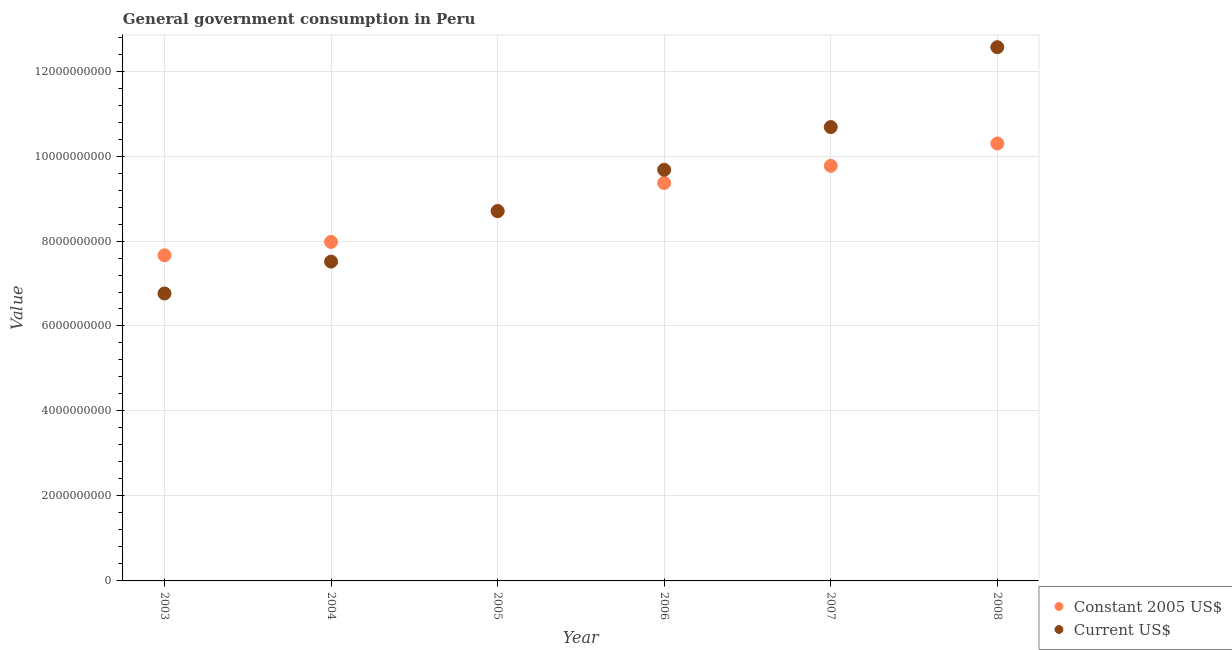Is the number of dotlines equal to the number of legend labels?
Give a very brief answer. Yes. What is the value consumed in current us$ in 2007?
Provide a short and direct response. 1.07e+1. Across all years, what is the maximum value consumed in constant 2005 us$?
Offer a very short reply. 1.03e+1. Across all years, what is the minimum value consumed in current us$?
Give a very brief answer. 6.77e+09. In which year was the value consumed in current us$ minimum?
Give a very brief answer. 2003. What is the total value consumed in current us$ in the graph?
Your response must be concise. 5.59e+1. What is the difference between the value consumed in constant 2005 us$ in 2007 and that in 2008?
Keep it short and to the point. -5.27e+08. What is the difference between the value consumed in constant 2005 us$ in 2006 and the value consumed in current us$ in 2005?
Provide a short and direct response. 6.61e+08. What is the average value consumed in constant 2005 us$ per year?
Your answer should be compact. 8.96e+09. In the year 2007, what is the difference between the value consumed in constant 2005 us$ and value consumed in current us$?
Your answer should be compact. -9.13e+08. In how many years, is the value consumed in current us$ greater than 11600000000?
Give a very brief answer. 1. What is the ratio of the value consumed in current us$ in 2006 to that in 2007?
Your answer should be compact. 0.91. Is the value consumed in current us$ in 2004 less than that in 2005?
Provide a short and direct response. Yes. What is the difference between the highest and the second highest value consumed in constant 2005 us$?
Your answer should be compact. 5.27e+08. What is the difference between the highest and the lowest value consumed in constant 2005 us$?
Offer a very short reply. 2.63e+09. Does the value consumed in current us$ monotonically increase over the years?
Your answer should be very brief. Yes. How many dotlines are there?
Give a very brief answer. 2. How many years are there in the graph?
Keep it short and to the point. 6. Are the values on the major ticks of Y-axis written in scientific E-notation?
Ensure brevity in your answer.  No. Does the graph contain grids?
Your response must be concise. Yes. How are the legend labels stacked?
Offer a very short reply. Vertical. What is the title of the graph?
Provide a short and direct response. General government consumption in Peru. What is the label or title of the Y-axis?
Provide a short and direct response. Value. What is the Value of Constant 2005 US$ in 2003?
Your response must be concise. 7.66e+09. What is the Value in Current US$ in 2003?
Ensure brevity in your answer.  6.77e+09. What is the Value in Constant 2005 US$ in 2004?
Keep it short and to the point. 7.98e+09. What is the Value in Current US$ in 2004?
Your answer should be compact. 7.52e+09. What is the Value of Constant 2005 US$ in 2005?
Ensure brevity in your answer.  8.70e+09. What is the Value of Current US$ in 2005?
Your response must be concise. 8.70e+09. What is the Value of Constant 2005 US$ in 2006?
Provide a short and direct response. 9.37e+09. What is the Value of Current US$ in 2006?
Give a very brief answer. 9.68e+09. What is the Value of Constant 2005 US$ in 2007?
Your response must be concise. 9.77e+09. What is the Value of Current US$ in 2007?
Your response must be concise. 1.07e+1. What is the Value of Constant 2005 US$ in 2008?
Give a very brief answer. 1.03e+1. What is the Value of Current US$ in 2008?
Provide a short and direct response. 1.26e+1. Across all years, what is the maximum Value of Constant 2005 US$?
Provide a succinct answer. 1.03e+1. Across all years, what is the maximum Value in Current US$?
Keep it short and to the point. 1.26e+1. Across all years, what is the minimum Value in Constant 2005 US$?
Give a very brief answer. 7.66e+09. Across all years, what is the minimum Value in Current US$?
Keep it short and to the point. 6.77e+09. What is the total Value of Constant 2005 US$ in the graph?
Your response must be concise. 5.38e+1. What is the total Value of Current US$ in the graph?
Ensure brevity in your answer.  5.59e+1. What is the difference between the Value of Constant 2005 US$ in 2003 and that in 2004?
Provide a short and direct response. -3.14e+08. What is the difference between the Value of Current US$ in 2003 and that in 2004?
Your answer should be compact. -7.51e+08. What is the difference between the Value in Constant 2005 US$ in 2003 and that in 2005?
Provide a short and direct response. -1.04e+09. What is the difference between the Value in Current US$ in 2003 and that in 2005?
Offer a very short reply. -1.94e+09. What is the difference between the Value of Constant 2005 US$ in 2003 and that in 2006?
Ensure brevity in your answer.  -1.70e+09. What is the difference between the Value in Current US$ in 2003 and that in 2006?
Your response must be concise. -2.91e+09. What is the difference between the Value of Constant 2005 US$ in 2003 and that in 2007?
Offer a terse response. -2.10e+09. What is the difference between the Value in Current US$ in 2003 and that in 2007?
Make the answer very short. -3.92e+09. What is the difference between the Value in Constant 2005 US$ in 2003 and that in 2008?
Make the answer very short. -2.63e+09. What is the difference between the Value of Current US$ in 2003 and that in 2008?
Offer a terse response. -5.80e+09. What is the difference between the Value of Constant 2005 US$ in 2004 and that in 2005?
Ensure brevity in your answer.  -7.26e+08. What is the difference between the Value of Current US$ in 2004 and that in 2005?
Provide a succinct answer. -1.19e+09. What is the difference between the Value of Constant 2005 US$ in 2004 and that in 2006?
Your answer should be compact. -1.39e+09. What is the difference between the Value of Current US$ in 2004 and that in 2006?
Offer a terse response. -2.16e+09. What is the difference between the Value of Constant 2005 US$ in 2004 and that in 2007?
Keep it short and to the point. -1.79e+09. What is the difference between the Value in Current US$ in 2004 and that in 2007?
Your response must be concise. -3.17e+09. What is the difference between the Value of Constant 2005 US$ in 2004 and that in 2008?
Your response must be concise. -2.32e+09. What is the difference between the Value of Current US$ in 2004 and that in 2008?
Offer a terse response. -5.05e+09. What is the difference between the Value in Constant 2005 US$ in 2005 and that in 2006?
Provide a succinct answer. -6.61e+08. What is the difference between the Value in Current US$ in 2005 and that in 2006?
Keep it short and to the point. -9.72e+08. What is the difference between the Value in Constant 2005 US$ in 2005 and that in 2007?
Your answer should be compact. -1.06e+09. What is the difference between the Value of Current US$ in 2005 and that in 2007?
Give a very brief answer. -1.98e+09. What is the difference between the Value of Constant 2005 US$ in 2005 and that in 2008?
Offer a terse response. -1.59e+09. What is the difference between the Value in Current US$ in 2005 and that in 2008?
Keep it short and to the point. -3.86e+09. What is the difference between the Value of Constant 2005 US$ in 2006 and that in 2007?
Offer a terse response. -4.03e+08. What is the difference between the Value in Current US$ in 2006 and that in 2007?
Your answer should be very brief. -1.01e+09. What is the difference between the Value of Constant 2005 US$ in 2006 and that in 2008?
Keep it short and to the point. -9.29e+08. What is the difference between the Value in Current US$ in 2006 and that in 2008?
Ensure brevity in your answer.  -2.89e+09. What is the difference between the Value of Constant 2005 US$ in 2007 and that in 2008?
Make the answer very short. -5.27e+08. What is the difference between the Value in Current US$ in 2007 and that in 2008?
Your response must be concise. -1.88e+09. What is the difference between the Value in Constant 2005 US$ in 2003 and the Value in Current US$ in 2004?
Offer a terse response. 1.49e+08. What is the difference between the Value in Constant 2005 US$ in 2003 and the Value in Current US$ in 2005?
Keep it short and to the point. -1.04e+09. What is the difference between the Value in Constant 2005 US$ in 2003 and the Value in Current US$ in 2006?
Your answer should be compact. -2.01e+09. What is the difference between the Value in Constant 2005 US$ in 2003 and the Value in Current US$ in 2007?
Your response must be concise. -3.02e+09. What is the difference between the Value in Constant 2005 US$ in 2003 and the Value in Current US$ in 2008?
Your response must be concise. -4.90e+09. What is the difference between the Value in Constant 2005 US$ in 2004 and the Value in Current US$ in 2005?
Offer a very short reply. -7.26e+08. What is the difference between the Value of Constant 2005 US$ in 2004 and the Value of Current US$ in 2006?
Offer a terse response. -1.70e+09. What is the difference between the Value in Constant 2005 US$ in 2004 and the Value in Current US$ in 2007?
Offer a terse response. -2.70e+09. What is the difference between the Value in Constant 2005 US$ in 2004 and the Value in Current US$ in 2008?
Your answer should be very brief. -4.58e+09. What is the difference between the Value in Constant 2005 US$ in 2005 and the Value in Current US$ in 2006?
Offer a very short reply. -9.72e+08. What is the difference between the Value of Constant 2005 US$ in 2005 and the Value of Current US$ in 2007?
Keep it short and to the point. -1.98e+09. What is the difference between the Value of Constant 2005 US$ in 2005 and the Value of Current US$ in 2008?
Your response must be concise. -3.86e+09. What is the difference between the Value in Constant 2005 US$ in 2006 and the Value in Current US$ in 2007?
Offer a very short reply. -1.32e+09. What is the difference between the Value in Constant 2005 US$ in 2006 and the Value in Current US$ in 2008?
Provide a short and direct response. -3.20e+09. What is the difference between the Value in Constant 2005 US$ in 2007 and the Value in Current US$ in 2008?
Offer a very short reply. -2.79e+09. What is the average Value of Constant 2005 US$ per year?
Offer a terse response. 8.96e+09. What is the average Value in Current US$ per year?
Ensure brevity in your answer.  9.32e+09. In the year 2003, what is the difference between the Value of Constant 2005 US$ and Value of Current US$?
Provide a short and direct response. 9.00e+08. In the year 2004, what is the difference between the Value of Constant 2005 US$ and Value of Current US$?
Ensure brevity in your answer.  4.63e+08. In the year 2006, what is the difference between the Value in Constant 2005 US$ and Value in Current US$?
Give a very brief answer. -3.11e+08. In the year 2007, what is the difference between the Value in Constant 2005 US$ and Value in Current US$?
Make the answer very short. -9.13e+08. In the year 2008, what is the difference between the Value in Constant 2005 US$ and Value in Current US$?
Offer a very short reply. -2.27e+09. What is the ratio of the Value of Constant 2005 US$ in 2003 to that in 2004?
Keep it short and to the point. 0.96. What is the ratio of the Value of Current US$ in 2003 to that in 2004?
Give a very brief answer. 0.9. What is the ratio of the Value in Constant 2005 US$ in 2003 to that in 2005?
Your answer should be very brief. 0.88. What is the ratio of the Value in Current US$ in 2003 to that in 2005?
Your answer should be very brief. 0.78. What is the ratio of the Value of Constant 2005 US$ in 2003 to that in 2006?
Provide a succinct answer. 0.82. What is the ratio of the Value in Current US$ in 2003 to that in 2006?
Give a very brief answer. 0.7. What is the ratio of the Value of Constant 2005 US$ in 2003 to that in 2007?
Your answer should be very brief. 0.78. What is the ratio of the Value of Current US$ in 2003 to that in 2007?
Your answer should be very brief. 0.63. What is the ratio of the Value of Constant 2005 US$ in 2003 to that in 2008?
Your answer should be very brief. 0.74. What is the ratio of the Value of Current US$ in 2003 to that in 2008?
Provide a succinct answer. 0.54. What is the ratio of the Value of Constant 2005 US$ in 2004 to that in 2005?
Give a very brief answer. 0.92. What is the ratio of the Value of Current US$ in 2004 to that in 2005?
Provide a short and direct response. 0.86. What is the ratio of the Value in Constant 2005 US$ in 2004 to that in 2006?
Provide a short and direct response. 0.85. What is the ratio of the Value of Current US$ in 2004 to that in 2006?
Provide a short and direct response. 0.78. What is the ratio of the Value in Constant 2005 US$ in 2004 to that in 2007?
Your answer should be compact. 0.82. What is the ratio of the Value in Current US$ in 2004 to that in 2007?
Your response must be concise. 0.7. What is the ratio of the Value in Constant 2005 US$ in 2004 to that in 2008?
Your response must be concise. 0.78. What is the ratio of the Value of Current US$ in 2004 to that in 2008?
Ensure brevity in your answer.  0.6. What is the ratio of the Value of Constant 2005 US$ in 2005 to that in 2006?
Make the answer very short. 0.93. What is the ratio of the Value in Current US$ in 2005 to that in 2006?
Your answer should be very brief. 0.9. What is the ratio of the Value in Constant 2005 US$ in 2005 to that in 2007?
Offer a very short reply. 0.89. What is the ratio of the Value of Current US$ in 2005 to that in 2007?
Provide a short and direct response. 0.81. What is the ratio of the Value of Constant 2005 US$ in 2005 to that in 2008?
Keep it short and to the point. 0.85. What is the ratio of the Value in Current US$ in 2005 to that in 2008?
Offer a terse response. 0.69. What is the ratio of the Value of Constant 2005 US$ in 2006 to that in 2007?
Offer a very short reply. 0.96. What is the ratio of the Value in Current US$ in 2006 to that in 2007?
Provide a short and direct response. 0.91. What is the ratio of the Value in Constant 2005 US$ in 2006 to that in 2008?
Offer a very short reply. 0.91. What is the ratio of the Value of Current US$ in 2006 to that in 2008?
Keep it short and to the point. 0.77. What is the ratio of the Value of Constant 2005 US$ in 2007 to that in 2008?
Provide a short and direct response. 0.95. What is the ratio of the Value in Current US$ in 2007 to that in 2008?
Give a very brief answer. 0.85. What is the difference between the highest and the second highest Value in Constant 2005 US$?
Ensure brevity in your answer.  5.27e+08. What is the difference between the highest and the second highest Value in Current US$?
Make the answer very short. 1.88e+09. What is the difference between the highest and the lowest Value in Constant 2005 US$?
Provide a short and direct response. 2.63e+09. What is the difference between the highest and the lowest Value in Current US$?
Your response must be concise. 5.80e+09. 